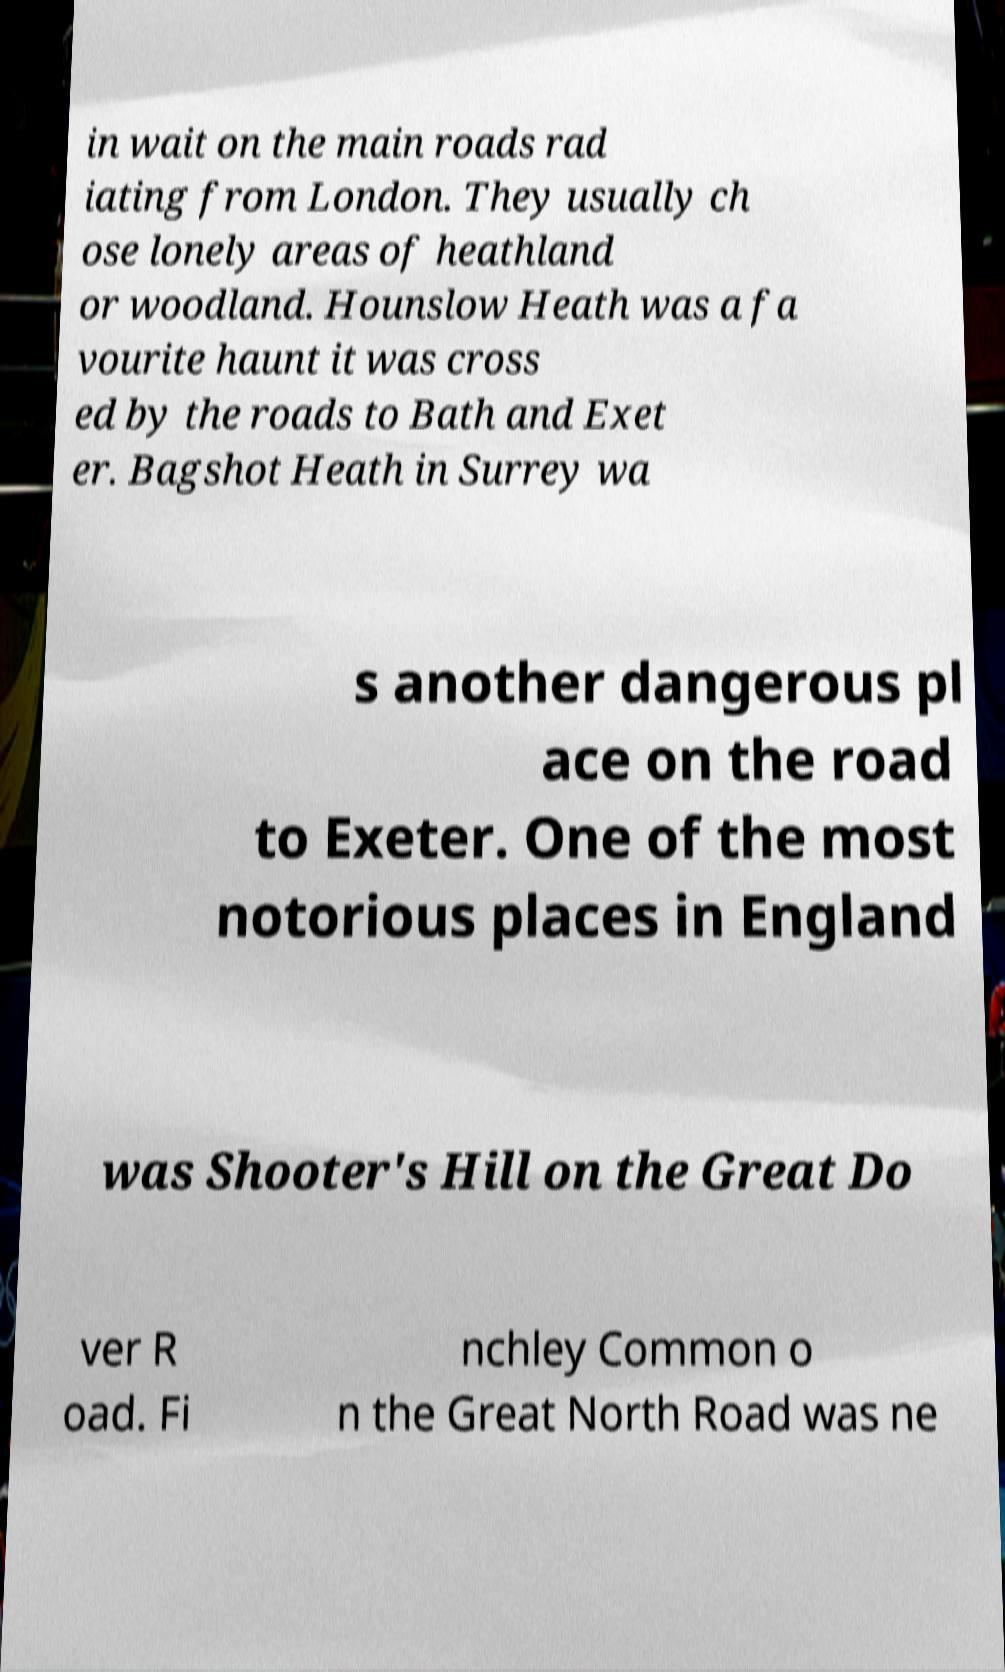Could you extract and type out the text from this image? in wait on the main roads rad iating from London. They usually ch ose lonely areas of heathland or woodland. Hounslow Heath was a fa vourite haunt it was cross ed by the roads to Bath and Exet er. Bagshot Heath in Surrey wa s another dangerous pl ace on the road to Exeter. One of the most notorious places in England was Shooter's Hill on the Great Do ver R oad. Fi nchley Common o n the Great North Road was ne 